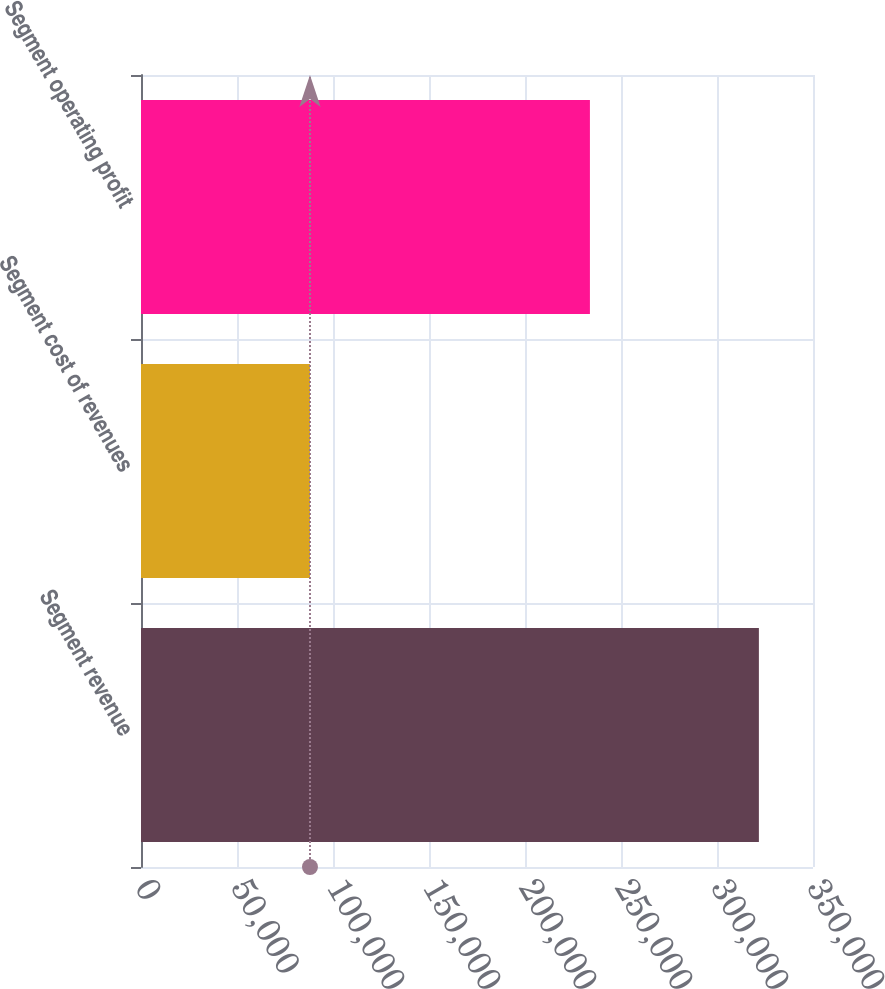Convert chart. <chart><loc_0><loc_0><loc_500><loc_500><bar_chart><fcel>Segment revenue<fcel>Segment cost of revenues<fcel>Segment operating profit<nl><fcel>321818<fcel>88006<fcel>233812<nl></chart> 